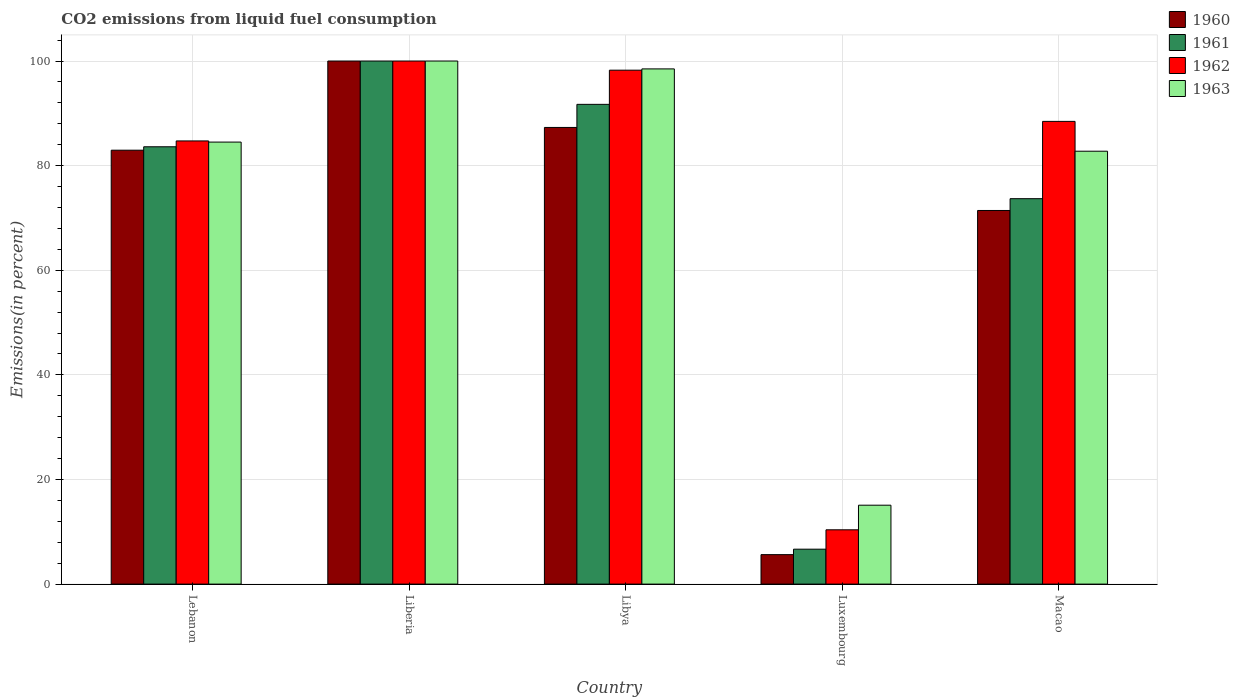Are the number of bars per tick equal to the number of legend labels?
Provide a short and direct response. Yes. How many bars are there on the 2nd tick from the right?
Give a very brief answer. 4. What is the label of the 4th group of bars from the left?
Keep it short and to the point. Luxembourg. What is the total CO2 emitted in 1960 in Luxembourg?
Give a very brief answer. 5.64. Across all countries, what is the minimum total CO2 emitted in 1962?
Your response must be concise. 10.38. In which country was the total CO2 emitted in 1963 maximum?
Provide a short and direct response. Liberia. In which country was the total CO2 emitted in 1963 minimum?
Your response must be concise. Luxembourg. What is the total total CO2 emitted in 1963 in the graph?
Give a very brief answer. 380.84. What is the difference between the total CO2 emitted in 1962 in Liberia and that in Luxembourg?
Your response must be concise. 89.62. What is the difference between the total CO2 emitted in 1962 in Liberia and the total CO2 emitted in 1961 in Luxembourg?
Ensure brevity in your answer.  93.32. What is the average total CO2 emitted in 1960 per country?
Your response must be concise. 69.46. In how many countries, is the total CO2 emitted in 1960 greater than 92 %?
Make the answer very short. 1. What is the ratio of the total CO2 emitted in 1963 in Liberia to that in Libya?
Make the answer very short. 1.02. Is the total CO2 emitted in 1960 in Liberia less than that in Luxembourg?
Your answer should be compact. No. Is the difference between the total CO2 emitted in 1962 in Lebanon and Luxembourg greater than the difference between the total CO2 emitted in 1961 in Lebanon and Luxembourg?
Offer a terse response. No. What is the difference between the highest and the second highest total CO2 emitted in 1963?
Provide a short and direct response. -1.5. What is the difference between the highest and the lowest total CO2 emitted in 1961?
Your response must be concise. 93.32. In how many countries, is the total CO2 emitted in 1962 greater than the average total CO2 emitted in 1962 taken over all countries?
Provide a succinct answer. 4. Is the sum of the total CO2 emitted in 1962 in Lebanon and Liberia greater than the maximum total CO2 emitted in 1961 across all countries?
Offer a very short reply. Yes. Is it the case that in every country, the sum of the total CO2 emitted in 1960 and total CO2 emitted in 1962 is greater than the sum of total CO2 emitted in 1961 and total CO2 emitted in 1963?
Keep it short and to the point. No. How many countries are there in the graph?
Keep it short and to the point. 5. Where does the legend appear in the graph?
Keep it short and to the point. Top right. How many legend labels are there?
Provide a succinct answer. 4. What is the title of the graph?
Your response must be concise. CO2 emissions from liquid fuel consumption. What is the label or title of the X-axis?
Your answer should be very brief. Country. What is the label or title of the Y-axis?
Offer a terse response. Emissions(in percent). What is the Emissions(in percent) of 1960 in Lebanon?
Provide a succinct answer. 82.95. What is the Emissions(in percent) of 1961 in Lebanon?
Ensure brevity in your answer.  83.61. What is the Emissions(in percent) in 1962 in Lebanon?
Keep it short and to the point. 84.72. What is the Emissions(in percent) of 1963 in Lebanon?
Your answer should be very brief. 84.5. What is the Emissions(in percent) in 1961 in Liberia?
Your answer should be compact. 100. What is the Emissions(in percent) in 1962 in Liberia?
Keep it short and to the point. 100. What is the Emissions(in percent) in 1963 in Liberia?
Your answer should be compact. 100. What is the Emissions(in percent) in 1960 in Libya?
Provide a succinct answer. 87.3. What is the Emissions(in percent) of 1961 in Libya?
Offer a very short reply. 91.72. What is the Emissions(in percent) in 1962 in Libya?
Offer a very short reply. 98.25. What is the Emissions(in percent) of 1963 in Libya?
Make the answer very short. 98.5. What is the Emissions(in percent) in 1960 in Luxembourg?
Your answer should be compact. 5.64. What is the Emissions(in percent) in 1961 in Luxembourg?
Make the answer very short. 6.68. What is the Emissions(in percent) of 1962 in Luxembourg?
Offer a terse response. 10.38. What is the Emissions(in percent) in 1963 in Luxembourg?
Offer a terse response. 15.09. What is the Emissions(in percent) of 1960 in Macao?
Give a very brief answer. 71.43. What is the Emissions(in percent) in 1961 in Macao?
Provide a short and direct response. 73.68. What is the Emissions(in percent) of 1962 in Macao?
Make the answer very short. 88.46. What is the Emissions(in percent) of 1963 in Macao?
Your answer should be very brief. 82.76. Across all countries, what is the maximum Emissions(in percent) in 1963?
Your response must be concise. 100. Across all countries, what is the minimum Emissions(in percent) in 1960?
Your response must be concise. 5.64. Across all countries, what is the minimum Emissions(in percent) in 1961?
Provide a short and direct response. 6.68. Across all countries, what is the minimum Emissions(in percent) in 1962?
Ensure brevity in your answer.  10.38. Across all countries, what is the minimum Emissions(in percent) of 1963?
Give a very brief answer. 15.09. What is the total Emissions(in percent) of 1960 in the graph?
Offer a terse response. 347.32. What is the total Emissions(in percent) of 1961 in the graph?
Give a very brief answer. 355.68. What is the total Emissions(in percent) in 1962 in the graph?
Provide a short and direct response. 381.82. What is the total Emissions(in percent) of 1963 in the graph?
Offer a terse response. 380.85. What is the difference between the Emissions(in percent) in 1960 in Lebanon and that in Liberia?
Provide a short and direct response. -17.05. What is the difference between the Emissions(in percent) of 1961 in Lebanon and that in Liberia?
Provide a short and direct response. -16.39. What is the difference between the Emissions(in percent) of 1962 in Lebanon and that in Liberia?
Your response must be concise. -15.28. What is the difference between the Emissions(in percent) of 1963 in Lebanon and that in Liberia?
Provide a succinct answer. -15.5. What is the difference between the Emissions(in percent) in 1960 in Lebanon and that in Libya?
Ensure brevity in your answer.  -4.35. What is the difference between the Emissions(in percent) in 1961 in Lebanon and that in Libya?
Give a very brief answer. -8.11. What is the difference between the Emissions(in percent) in 1962 in Lebanon and that in Libya?
Your answer should be very brief. -13.53. What is the difference between the Emissions(in percent) of 1963 in Lebanon and that in Libya?
Offer a terse response. -13.99. What is the difference between the Emissions(in percent) in 1960 in Lebanon and that in Luxembourg?
Keep it short and to the point. 77.32. What is the difference between the Emissions(in percent) of 1961 in Lebanon and that in Luxembourg?
Make the answer very short. 76.93. What is the difference between the Emissions(in percent) in 1962 in Lebanon and that in Luxembourg?
Provide a succinct answer. 74.34. What is the difference between the Emissions(in percent) in 1963 in Lebanon and that in Luxembourg?
Keep it short and to the point. 69.42. What is the difference between the Emissions(in percent) in 1960 in Lebanon and that in Macao?
Offer a very short reply. 11.53. What is the difference between the Emissions(in percent) of 1961 in Lebanon and that in Macao?
Provide a succinct answer. 9.92. What is the difference between the Emissions(in percent) in 1962 in Lebanon and that in Macao?
Ensure brevity in your answer.  -3.74. What is the difference between the Emissions(in percent) in 1963 in Lebanon and that in Macao?
Make the answer very short. 1.75. What is the difference between the Emissions(in percent) of 1960 in Liberia and that in Libya?
Your response must be concise. 12.7. What is the difference between the Emissions(in percent) in 1961 in Liberia and that in Libya?
Your answer should be very brief. 8.28. What is the difference between the Emissions(in percent) in 1962 in Liberia and that in Libya?
Offer a terse response. 1.75. What is the difference between the Emissions(in percent) in 1963 in Liberia and that in Libya?
Provide a succinct answer. 1.5. What is the difference between the Emissions(in percent) in 1960 in Liberia and that in Luxembourg?
Ensure brevity in your answer.  94.36. What is the difference between the Emissions(in percent) in 1961 in Liberia and that in Luxembourg?
Provide a short and direct response. 93.32. What is the difference between the Emissions(in percent) in 1962 in Liberia and that in Luxembourg?
Offer a terse response. 89.62. What is the difference between the Emissions(in percent) in 1963 in Liberia and that in Luxembourg?
Offer a terse response. 84.91. What is the difference between the Emissions(in percent) of 1960 in Liberia and that in Macao?
Keep it short and to the point. 28.57. What is the difference between the Emissions(in percent) of 1961 in Liberia and that in Macao?
Offer a very short reply. 26.32. What is the difference between the Emissions(in percent) of 1962 in Liberia and that in Macao?
Offer a terse response. 11.54. What is the difference between the Emissions(in percent) of 1963 in Liberia and that in Macao?
Make the answer very short. 17.24. What is the difference between the Emissions(in percent) of 1960 in Libya and that in Luxembourg?
Offer a very short reply. 81.67. What is the difference between the Emissions(in percent) of 1961 in Libya and that in Luxembourg?
Your response must be concise. 85.04. What is the difference between the Emissions(in percent) of 1962 in Libya and that in Luxembourg?
Your response must be concise. 87.87. What is the difference between the Emissions(in percent) of 1963 in Libya and that in Luxembourg?
Keep it short and to the point. 83.41. What is the difference between the Emissions(in percent) of 1960 in Libya and that in Macao?
Provide a short and direct response. 15.87. What is the difference between the Emissions(in percent) in 1961 in Libya and that in Macao?
Offer a very short reply. 18.03. What is the difference between the Emissions(in percent) in 1962 in Libya and that in Macao?
Give a very brief answer. 9.79. What is the difference between the Emissions(in percent) of 1963 in Libya and that in Macao?
Make the answer very short. 15.74. What is the difference between the Emissions(in percent) of 1960 in Luxembourg and that in Macao?
Give a very brief answer. -65.79. What is the difference between the Emissions(in percent) in 1961 in Luxembourg and that in Macao?
Give a very brief answer. -67.01. What is the difference between the Emissions(in percent) in 1962 in Luxembourg and that in Macao?
Your response must be concise. -78.08. What is the difference between the Emissions(in percent) in 1963 in Luxembourg and that in Macao?
Provide a succinct answer. -67.67. What is the difference between the Emissions(in percent) in 1960 in Lebanon and the Emissions(in percent) in 1961 in Liberia?
Make the answer very short. -17.05. What is the difference between the Emissions(in percent) in 1960 in Lebanon and the Emissions(in percent) in 1962 in Liberia?
Ensure brevity in your answer.  -17.05. What is the difference between the Emissions(in percent) in 1960 in Lebanon and the Emissions(in percent) in 1963 in Liberia?
Ensure brevity in your answer.  -17.05. What is the difference between the Emissions(in percent) in 1961 in Lebanon and the Emissions(in percent) in 1962 in Liberia?
Offer a very short reply. -16.39. What is the difference between the Emissions(in percent) of 1961 in Lebanon and the Emissions(in percent) of 1963 in Liberia?
Offer a terse response. -16.39. What is the difference between the Emissions(in percent) of 1962 in Lebanon and the Emissions(in percent) of 1963 in Liberia?
Offer a terse response. -15.28. What is the difference between the Emissions(in percent) in 1960 in Lebanon and the Emissions(in percent) in 1961 in Libya?
Ensure brevity in your answer.  -8.76. What is the difference between the Emissions(in percent) of 1960 in Lebanon and the Emissions(in percent) of 1962 in Libya?
Ensure brevity in your answer.  -15.3. What is the difference between the Emissions(in percent) of 1960 in Lebanon and the Emissions(in percent) of 1963 in Libya?
Your answer should be compact. -15.54. What is the difference between the Emissions(in percent) of 1961 in Lebanon and the Emissions(in percent) of 1962 in Libya?
Give a very brief answer. -14.65. What is the difference between the Emissions(in percent) of 1961 in Lebanon and the Emissions(in percent) of 1963 in Libya?
Your answer should be compact. -14.89. What is the difference between the Emissions(in percent) in 1962 in Lebanon and the Emissions(in percent) in 1963 in Libya?
Ensure brevity in your answer.  -13.77. What is the difference between the Emissions(in percent) of 1960 in Lebanon and the Emissions(in percent) of 1961 in Luxembourg?
Provide a short and direct response. 76.28. What is the difference between the Emissions(in percent) in 1960 in Lebanon and the Emissions(in percent) in 1962 in Luxembourg?
Provide a short and direct response. 72.57. What is the difference between the Emissions(in percent) of 1960 in Lebanon and the Emissions(in percent) of 1963 in Luxembourg?
Provide a short and direct response. 67.87. What is the difference between the Emissions(in percent) in 1961 in Lebanon and the Emissions(in percent) in 1962 in Luxembourg?
Keep it short and to the point. 73.23. What is the difference between the Emissions(in percent) of 1961 in Lebanon and the Emissions(in percent) of 1963 in Luxembourg?
Offer a terse response. 68.52. What is the difference between the Emissions(in percent) in 1962 in Lebanon and the Emissions(in percent) in 1963 in Luxembourg?
Provide a succinct answer. 69.64. What is the difference between the Emissions(in percent) in 1960 in Lebanon and the Emissions(in percent) in 1961 in Macao?
Your response must be concise. 9.27. What is the difference between the Emissions(in percent) of 1960 in Lebanon and the Emissions(in percent) of 1962 in Macao?
Your response must be concise. -5.51. What is the difference between the Emissions(in percent) in 1960 in Lebanon and the Emissions(in percent) in 1963 in Macao?
Offer a very short reply. 0.2. What is the difference between the Emissions(in percent) in 1961 in Lebanon and the Emissions(in percent) in 1962 in Macao?
Your response must be concise. -4.86. What is the difference between the Emissions(in percent) of 1961 in Lebanon and the Emissions(in percent) of 1963 in Macao?
Ensure brevity in your answer.  0.85. What is the difference between the Emissions(in percent) of 1962 in Lebanon and the Emissions(in percent) of 1963 in Macao?
Offer a very short reply. 1.97. What is the difference between the Emissions(in percent) in 1960 in Liberia and the Emissions(in percent) in 1961 in Libya?
Give a very brief answer. 8.28. What is the difference between the Emissions(in percent) of 1960 in Liberia and the Emissions(in percent) of 1962 in Libya?
Your response must be concise. 1.75. What is the difference between the Emissions(in percent) in 1960 in Liberia and the Emissions(in percent) in 1963 in Libya?
Provide a succinct answer. 1.5. What is the difference between the Emissions(in percent) in 1961 in Liberia and the Emissions(in percent) in 1962 in Libya?
Provide a short and direct response. 1.75. What is the difference between the Emissions(in percent) in 1961 in Liberia and the Emissions(in percent) in 1963 in Libya?
Your answer should be compact. 1.5. What is the difference between the Emissions(in percent) in 1962 in Liberia and the Emissions(in percent) in 1963 in Libya?
Your answer should be very brief. 1.5. What is the difference between the Emissions(in percent) in 1960 in Liberia and the Emissions(in percent) in 1961 in Luxembourg?
Keep it short and to the point. 93.32. What is the difference between the Emissions(in percent) of 1960 in Liberia and the Emissions(in percent) of 1962 in Luxembourg?
Offer a very short reply. 89.62. What is the difference between the Emissions(in percent) of 1960 in Liberia and the Emissions(in percent) of 1963 in Luxembourg?
Offer a very short reply. 84.91. What is the difference between the Emissions(in percent) of 1961 in Liberia and the Emissions(in percent) of 1962 in Luxembourg?
Keep it short and to the point. 89.62. What is the difference between the Emissions(in percent) in 1961 in Liberia and the Emissions(in percent) in 1963 in Luxembourg?
Your response must be concise. 84.91. What is the difference between the Emissions(in percent) of 1962 in Liberia and the Emissions(in percent) of 1963 in Luxembourg?
Your answer should be compact. 84.91. What is the difference between the Emissions(in percent) in 1960 in Liberia and the Emissions(in percent) in 1961 in Macao?
Offer a terse response. 26.32. What is the difference between the Emissions(in percent) in 1960 in Liberia and the Emissions(in percent) in 1962 in Macao?
Your answer should be compact. 11.54. What is the difference between the Emissions(in percent) in 1960 in Liberia and the Emissions(in percent) in 1963 in Macao?
Your response must be concise. 17.24. What is the difference between the Emissions(in percent) in 1961 in Liberia and the Emissions(in percent) in 1962 in Macao?
Give a very brief answer. 11.54. What is the difference between the Emissions(in percent) in 1961 in Liberia and the Emissions(in percent) in 1963 in Macao?
Give a very brief answer. 17.24. What is the difference between the Emissions(in percent) of 1962 in Liberia and the Emissions(in percent) of 1963 in Macao?
Give a very brief answer. 17.24. What is the difference between the Emissions(in percent) of 1960 in Libya and the Emissions(in percent) of 1961 in Luxembourg?
Make the answer very short. 80.63. What is the difference between the Emissions(in percent) of 1960 in Libya and the Emissions(in percent) of 1962 in Luxembourg?
Provide a short and direct response. 76.92. What is the difference between the Emissions(in percent) in 1960 in Libya and the Emissions(in percent) in 1963 in Luxembourg?
Provide a succinct answer. 72.22. What is the difference between the Emissions(in percent) of 1961 in Libya and the Emissions(in percent) of 1962 in Luxembourg?
Provide a succinct answer. 81.34. What is the difference between the Emissions(in percent) of 1961 in Libya and the Emissions(in percent) of 1963 in Luxembourg?
Provide a short and direct response. 76.63. What is the difference between the Emissions(in percent) of 1962 in Libya and the Emissions(in percent) of 1963 in Luxembourg?
Your answer should be very brief. 83.17. What is the difference between the Emissions(in percent) of 1960 in Libya and the Emissions(in percent) of 1961 in Macao?
Keep it short and to the point. 13.62. What is the difference between the Emissions(in percent) of 1960 in Libya and the Emissions(in percent) of 1962 in Macao?
Your answer should be very brief. -1.16. What is the difference between the Emissions(in percent) of 1960 in Libya and the Emissions(in percent) of 1963 in Macao?
Make the answer very short. 4.54. What is the difference between the Emissions(in percent) in 1961 in Libya and the Emissions(in percent) in 1962 in Macao?
Make the answer very short. 3.26. What is the difference between the Emissions(in percent) of 1961 in Libya and the Emissions(in percent) of 1963 in Macao?
Offer a very short reply. 8.96. What is the difference between the Emissions(in percent) of 1962 in Libya and the Emissions(in percent) of 1963 in Macao?
Offer a terse response. 15.49. What is the difference between the Emissions(in percent) in 1960 in Luxembourg and the Emissions(in percent) in 1961 in Macao?
Your answer should be compact. -68.05. What is the difference between the Emissions(in percent) of 1960 in Luxembourg and the Emissions(in percent) of 1962 in Macao?
Your response must be concise. -82.83. What is the difference between the Emissions(in percent) in 1960 in Luxembourg and the Emissions(in percent) in 1963 in Macao?
Keep it short and to the point. -77.12. What is the difference between the Emissions(in percent) of 1961 in Luxembourg and the Emissions(in percent) of 1962 in Macao?
Offer a very short reply. -81.79. What is the difference between the Emissions(in percent) of 1961 in Luxembourg and the Emissions(in percent) of 1963 in Macao?
Your response must be concise. -76.08. What is the difference between the Emissions(in percent) in 1962 in Luxembourg and the Emissions(in percent) in 1963 in Macao?
Offer a very short reply. -72.38. What is the average Emissions(in percent) of 1960 per country?
Provide a succinct answer. 69.46. What is the average Emissions(in percent) in 1961 per country?
Make the answer very short. 71.14. What is the average Emissions(in percent) in 1962 per country?
Your answer should be very brief. 76.36. What is the average Emissions(in percent) in 1963 per country?
Your response must be concise. 76.17. What is the difference between the Emissions(in percent) in 1960 and Emissions(in percent) in 1961 in Lebanon?
Keep it short and to the point. -0.65. What is the difference between the Emissions(in percent) of 1960 and Emissions(in percent) of 1962 in Lebanon?
Keep it short and to the point. -1.77. What is the difference between the Emissions(in percent) in 1960 and Emissions(in percent) in 1963 in Lebanon?
Give a very brief answer. -1.55. What is the difference between the Emissions(in percent) in 1961 and Emissions(in percent) in 1962 in Lebanon?
Give a very brief answer. -1.12. What is the difference between the Emissions(in percent) of 1961 and Emissions(in percent) of 1963 in Lebanon?
Provide a short and direct response. -0.9. What is the difference between the Emissions(in percent) of 1962 and Emissions(in percent) of 1963 in Lebanon?
Your answer should be compact. 0.22. What is the difference between the Emissions(in percent) in 1960 and Emissions(in percent) in 1961 in Liberia?
Offer a very short reply. 0. What is the difference between the Emissions(in percent) of 1960 and Emissions(in percent) of 1963 in Liberia?
Provide a succinct answer. 0. What is the difference between the Emissions(in percent) in 1961 and Emissions(in percent) in 1962 in Liberia?
Your answer should be very brief. 0. What is the difference between the Emissions(in percent) of 1962 and Emissions(in percent) of 1963 in Liberia?
Your answer should be compact. 0. What is the difference between the Emissions(in percent) of 1960 and Emissions(in percent) of 1961 in Libya?
Your answer should be compact. -4.42. What is the difference between the Emissions(in percent) of 1960 and Emissions(in percent) of 1962 in Libya?
Your response must be concise. -10.95. What is the difference between the Emissions(in percent) of 1960 and Emissions(in percent) of 1963 in Libya?
Make the answer very short. -11.19. What is the difference between the Emissions(in percent) in 1961 and Emissions(in percent) in 1962 in Libya?
Provide a short and direct response. -6.53. What is the difference between the Emissions(in percent) in 1961 and Emissions(in percent) in 1963 in Libya?
Your response must be concise. -6.78. What is the difference between the Emissions(in percent) in 1962 and Emissions(in percent) in 1963 in Libya?
Offer a very short reply. -0.24. What is the difference between the Emissions(in percent) in 1960 and Emissions(in percent) in 1961 in Luxembourg?
Give a very brief answer. -1.04. What is the difference between the Emissions(in percent) of 1960 and Emissions(in percent) of 1962 in Luxembourg?
Keep it short and to the point. -4.75. What is the difference between the Emissions(in percent) of 1960 and Emissions(in percent) of 1963 in Luxembourg?
Ensure brevity in your answer.  -9.45. What is the difference between the Emissions(in percent) of 1961 and Emissions(in percent) of 1962 in Luxembourg?
Give a very brief answer. -3.71. What is the difference between the Emissions(in percent) of 1961 and Emissions(in percent) of 1963 in Luxembourg?
Offer a very short reply. -8.41. What is the difference between the Emissions(in percent) in 1962 and Emissions(in percent) in 1963 in Luxembourg?
Keep it short and to the point. -4.71. What is the difference between the Emissions(in percent) of 1960 and Emissions(in percent) of 1961 in Macao?
Offer a very short reply. -2.26. What is the difference between the Emissions(in percent) of 1960 and Emissions(in percent) of 1962 in Macao?
Keep it short and to the point. -17.03. What is the difference between the Emissions(in percent) in 1960 and Emissions(in percent) in 1963 in Macao?
Offer a very short reply. -11.33. What is the difference between the Emissions(in percent) of 1961 and Emissions(in percent) of 1962 in Macao?
Ensure brevity in your answer.  -14.78. What is the difference between the Emissions(in percent) of 1961 and Emissions(in percent) of 1963 in Macao?
Provide a succinct answer. -9.07. What is the difference between the Emissions(in percent) in 1962 and Emissions(in percent) in 1963 in Macao?
Keep it short and to the point. 5.7. What is the ratio of the Emissions(in percent) of 1960 in Lebanon to that in Liberia?
Make the answer very short. 0.83. What is the ratio of the Emissions(in percent) in 1961 in Lebanon to that in Liberia?
Give a very brief answer. 0.84. What is the ratio of the Emissions(in percent) in 1962 in Lebanon to that in Liberia?
Offer a terse response. 0.85. What is the ratio of the Emissions(in percent) of 1963 in Lebanon to that in Liberia?
Your answer should be very brief. 0.84. What is the ratio of the Emissions(in percent) in 1960 in Lebanon to that in Libya?
Ensure brevity in your answer.  0.95. What is the ratio of the Emissions(in percent) of 1961 in Lebanon to that in Libya?
Your answer should be very brief. 0.91. What is the ratio of the Emissions(in percent) in 1962 in Lebanon to that in Libya?
Give a very brief answer. 0.86. What is the ratio of the Emissions(in percent) of 1963 in Lebanon to that in Libya?
Make the answer very short. 0.86. What is the ratio of the Emissions(in percent) in 1960 in Lebanon to that in Luxembourg?
Your answer should be compact. 14.72. What is the ratio of the Emissions(in percent) in 1961 in Lebanon to that in Luxembourg?
Offer a very short reply. 12.53. What is the ratio of the Emissions(in percent) in 1962 in Lebanon to that in Luxembourg?
Offer a terse response. 8.16. What is the ratio of the Emissions(in percent) in 1963 in Lebanon to that in Luxembourg?
Provide a succinct answer. 5.6. What is the ratio of the Emissions(in percent) in 1960 in Lebanon to that in Macao?
Give a very brief answer. 1.16. What is the ratio of the Emissions(in percent) of 1961 in Lebanon to that in Macao?
Ensure brevity in your answer.  1.13. What is the ratio of the Emissions(in percent) of 1962 in Lebanon to that in Macao?
Keep it short and to the point. 0.96. What is the ratio of the Emissions(in percent) in 1963 in Lebanon to that in Macao?
Provide a succinct answer. 1.02. What is the ratio of the Emissions(in percent) in 1960 in Liberia to that in Libya?
Your answer should be very brief. 1.15. What is the ratio of the Emissions(in percent) in 1961 in Liberia to that in Libya?
Offer a very short reply. 1.09. What is the ratio of the Emissions(in percent) of 1962 in Liberia to that in Libya?
Offer a terse response. 1.02. What is the ratio of the Emissions(in percent) in 1963 in Liberia to that in Libya?
Your response must be concise. 1.02. What is the ratio of the Emissions(in percent) of 1960 in Liberia to that in Luxembourg?
Offer a very short reply. 17.75. What is the ratio of the Emissions(in percent) in 1961 in Liberia to that in Luxembourg?
Your answer should be compact. 14.98. What is the ratio of the Emissions(in percent) in 1962 in Liberia to that in Luxembourg?
Give a very brief answer. 9.63. What is the ratio of the Emissions(in percent) of 1963 in Liberia to that in Luxembourg?
Your answer should be very brief. 6.63. What is the ratio of the Emissions(in percent) in 1961 in Liberia to that in Macao?
Ensure brevity in your answer.  1.36. What is the ratio of the Emissions(in percent) of 1962 in Liberia to that in Macao?
Your answer should be compact. 1.13. What is the ratio of the Emissions(in percent) of 1963 in Liberia to that in Macao?
Give a very brief answer. 1.21. What is the ratio of the Emissions(in percent) in 1960 in Libya to that in Luxembourg?
Keep it short and to the point. 15.49. What is the ratio of the Emissions(in percent) in 1961 in Libya to that in Luxembourg?
Offer a terse response. 13.74. What is the ratio of the Emissions(in percent) of 1962 in Libya to that in Luxembourg?
Your answer should be very brief. 9.46. What is the ratio of the Emissions(in percent) in 1963 in Libya to that in Luxembourg?
Provide a succinct answer. 6.53. What is the ratio of the Emissions(in percent) of 1960 in Libya to that in Macao?
Your answer should be compact. 1.22. What is the ratio of the Emissions(in percent) of 1961 in Libya to that in Macao?
Keep it short and to the point. 1.24. What is the ratio of the Emissions(in percent) in 1962 in Libya to that in Macao?
Offer a terse response. 1.11. What is the ratio of the Emissions(in percent) in 1963 in Libya to that in Macao?
Provide a short and direct response. 1.19. What is the ratio of the Emissions(in percent) in 1960 in Luxembourg to that in Macao?
Your answer should be very brief. 0.08. What is the ratio of the Emissions(in percent) in 1961 in Luxembourg to that in Macao?
Provide a succinct answer. 0.09. What is the ratio of the Emissions(in percent) of 1962 in Luxembourg to that in Macao?
Your answer should be compact. 0.12. What is the ratio of the Emissions(in percent) of 1963 in Luxembourg to that in Macao?
Ensure brevity in your answer.  0.18. What is the difference between the highest and the second highest Emissions(in percent) in 1960?
Make the answer very short. 12.7. What is the difference between the highest and the second highest Emissions(in percent) of 1961?
Provide a short and direct response. 8.28. What is the difference between the highest and the second highest Emissions(in percent) of 1962?
Provide a short and direct response. 1.75. What is the difference between the highest and the second highest Emissions(in percent) of 1963?
Your response must be concise. 1.5. What is the difference between the highest and the lowest Emissions(in percent) of 1960?
Make the answer very short. 94.36. What is the difference between the highest and the lowest Emissions(in percent) in 1961?
Your response must be concise. 93.32. What is the difference between the highest and the lowest Emissions(in percent) of 1962?
Your answer should be very brief. 89.62. What is the difference between the highest and the lowest Emissions(in percent) in 1963?
Provide a short and direct response. 84.91. 